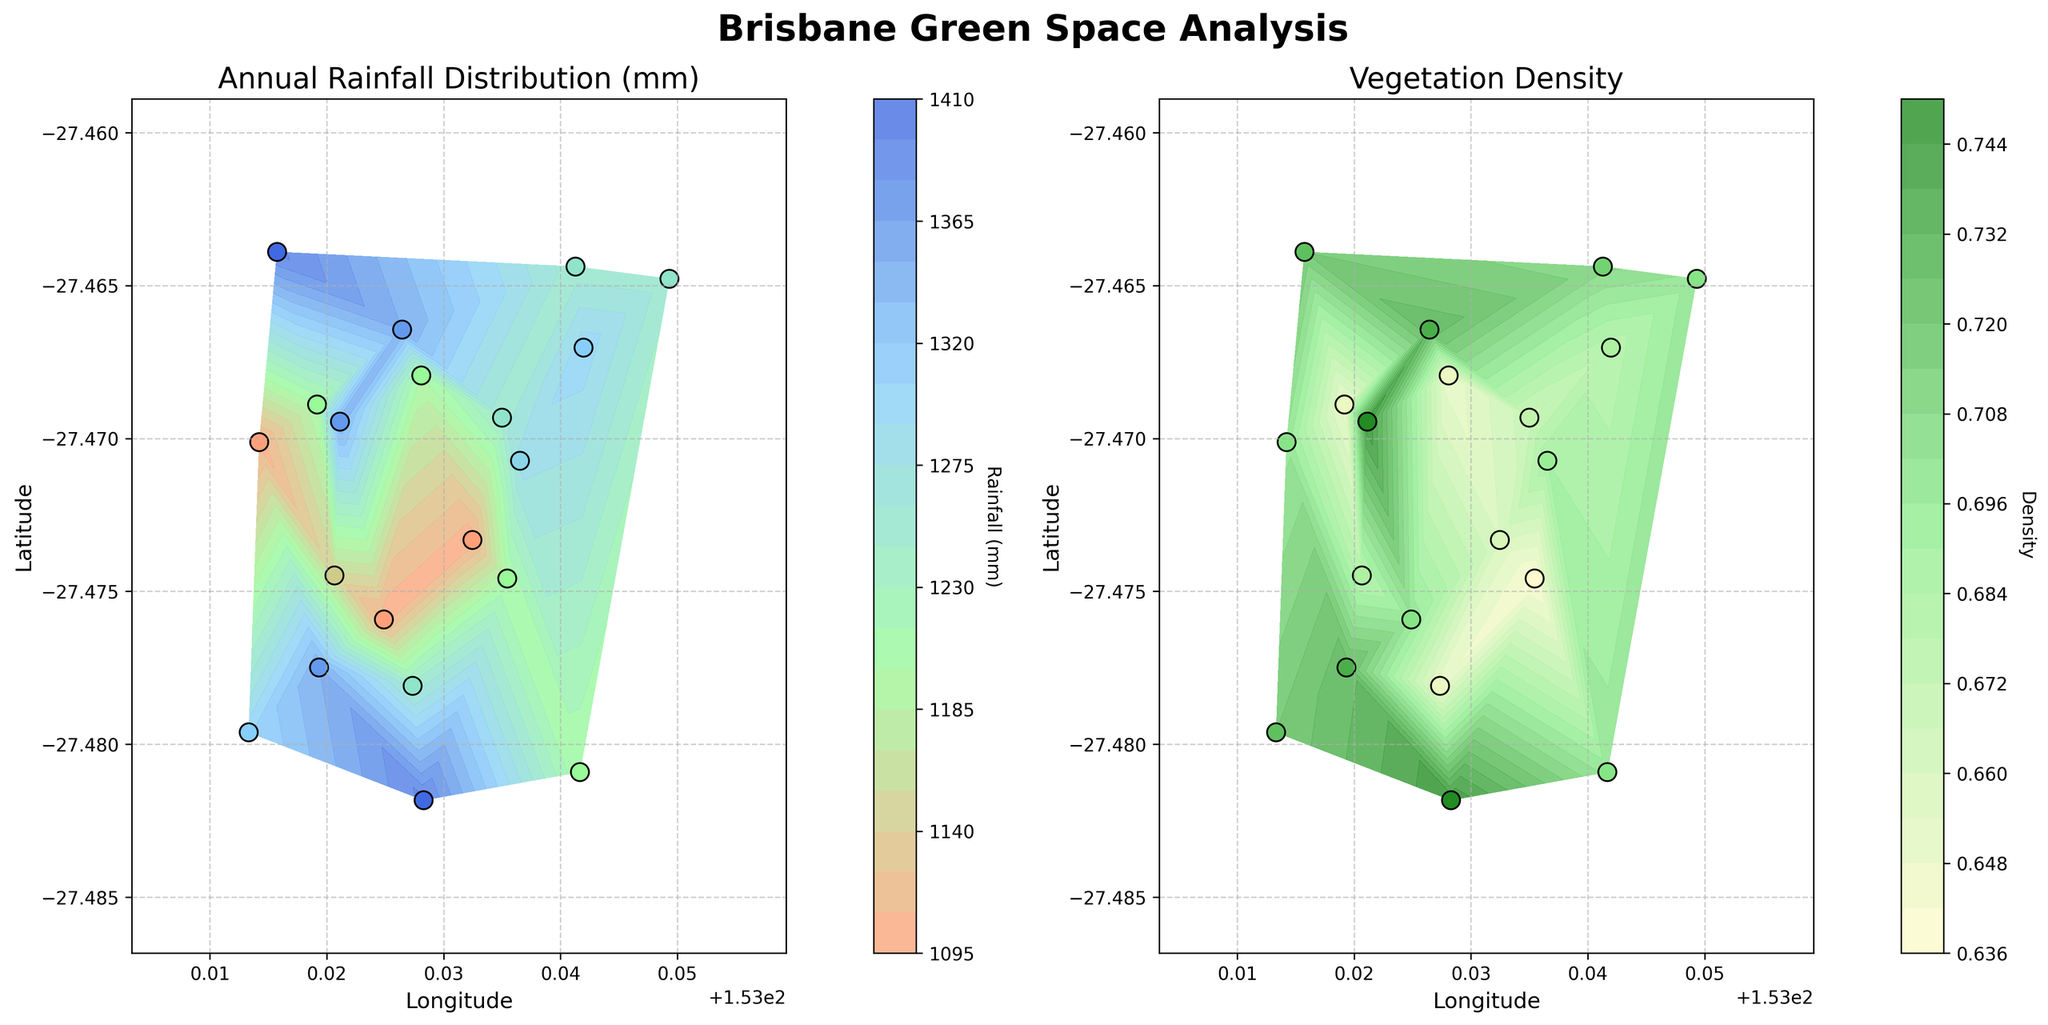What are the titles for the two subplots? The titles are stated at the top of each subplot. They provide an overview of what each subplot represents: the left subplot's title is "Annual Rainfall Distribution (mm)", and the right subplot's title is "Vegetation Density".
Answer: "Annual Rainfall Distribution (mm)" and "Vegetation Density" How does the vegetation density generally change in areas with higher rainfall? By observing the color gradients and the scatter plot data points, it is evident that areas with higher rainfall (darker blue colors) tend to correspond with higher vegetation density (darker green colors). This suggests a positive correlation between higher rainfall and increased vegetation density.
Answer: Positive correlation Which subplot displays information about vegetation density? Each subplot is titled, and the right subplot is specifically titled "Vegetation Density", indicating it contains the vegetation density information.
Answer: The right subplot Which range of colors is used to represent the annual rainfall distribution on the left subplot? The rainfall distribution is represented by a gradient of colors: from light pink to green, then to light blue, and finally dark blue, as seen in the color bar to the right of the left subplot.
Answer: Light pink to dark blue At longitude 153.02809 and latitude -27.46794, what is the approximate annual rainfall? Locate the coordinates (153.02809, -27.46794) on the left subplot and use the color gradient to estimate the rainfall, which corresponds to a dark blue color indicating an annual rainfall of approximately 1200 mm.
Answer: Approximately 1200 mm Comparing the scatter points, which area has the highest vegetation density? By comparing the color and density of scatter points in the right subplot, the area with coordinates around longitude 153.02829 and latitude -27.48183 displays the highest vegetation density with a color indicating the maximum density of 0.75.
Answer: Around longitude 153.02829 and latitude -27.48183 What is the range of vegetation density values shown in the color bar of the right subplot? The vegetation density ranges from light yellow colors representing lower values to dark green colors representing higher values, with a scale from approximately 0.64 to 0.75 as indicated by the color bar.
Answer: Approximately 0.64 to 0.75 Considering both subplots, where would you prioritize creating new green spaces in Brisbane? Reviewing both subplots, areas with lower relative vegetation density despite having sufficient rainfall, such as around coordinates longitude 153.035 and latitude -27.46478, could be targeted for more green spaces to balance vegetation density across the city.
Answer: Around longitude 153.035 and latitude -27.46478 What are the longitude and latitude bounds for the figures? The bounds for latitude and longitude can be inferred from the axes in both subplots indicating coordinates ranging approximately from latitude -27.48183 to -27.46390 and longitude 153.01332 to 153.04933.
Answer: Latitude -27.48183 to -27.46390 and Longitude 153.01332 to 153.04933 Is vegetation density above 0.7 found in areas with rainfall below 1200 mm? By correlating high vegetation density (values above 0.7 in dark green) in the right subplot with rainfall values in the left subplot, it can be seen that such vegetation density is not found in areas with rainfall below 1200 mm (light blue and lighter).
Answer: No 